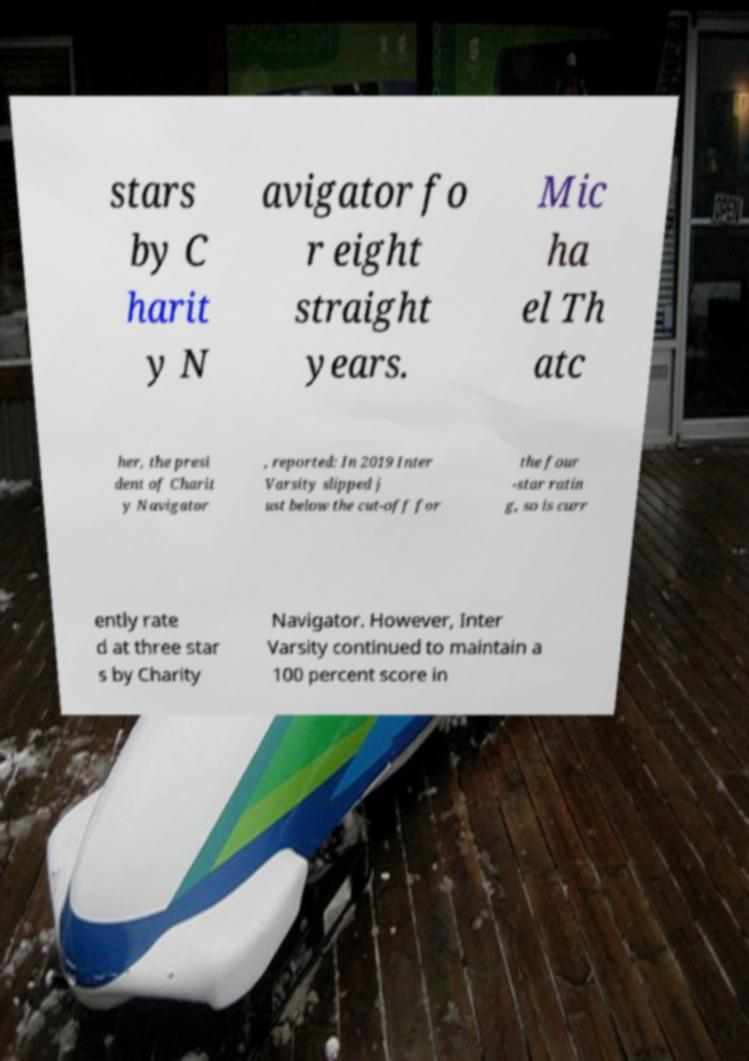Can you accurately transcribe the text from the provided image for me? stars by C harit y N avigator fo r eight straight years. Mic ha el Th atc her, the presi dent of Charit y Navigator , reported: In 2019 Inter Varsity slipped j ust below the cut-off for the four -star ratin g, so is curr ently rate d at three star s by Charity Navigator. However, Inter Varsity continued to maintain a 100 percent score in 